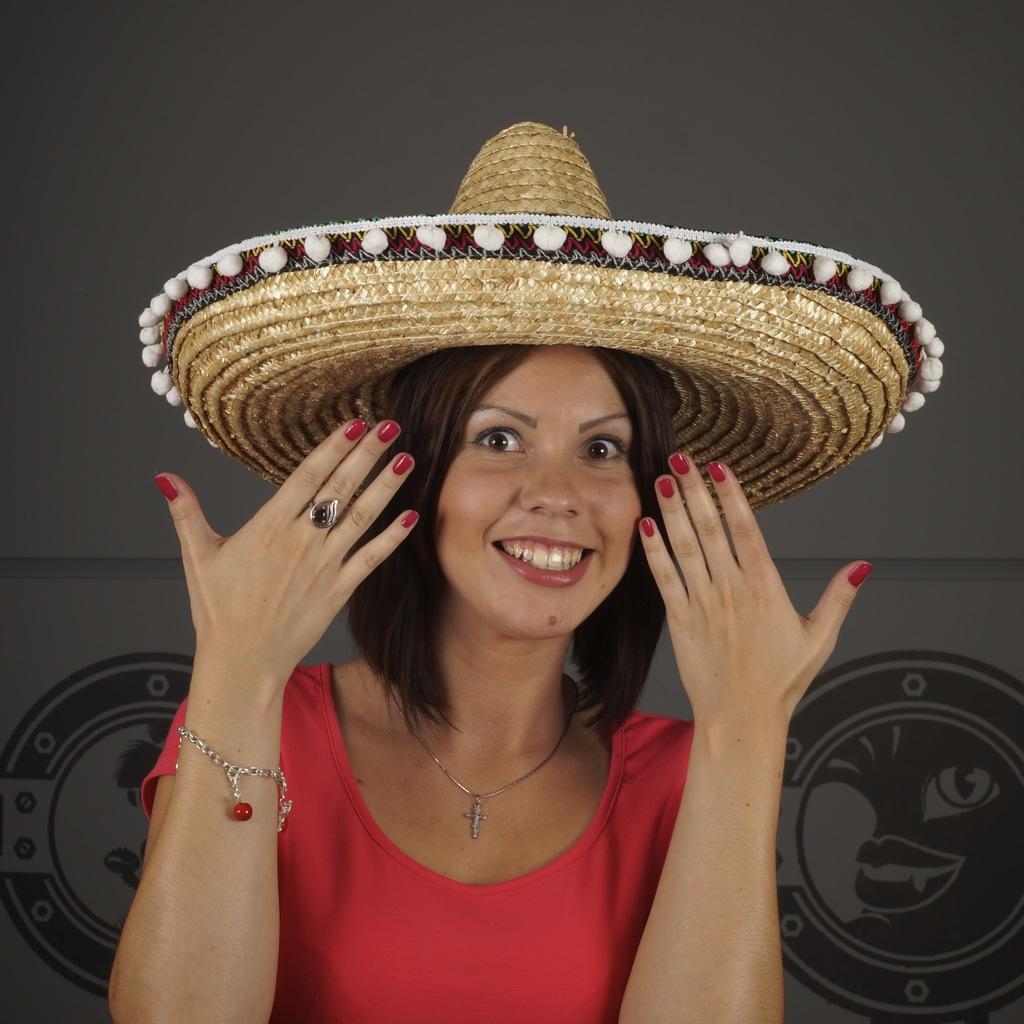In one or two sentences, can you explain what this image depicts? In this image we can see a lady wearing hat. 